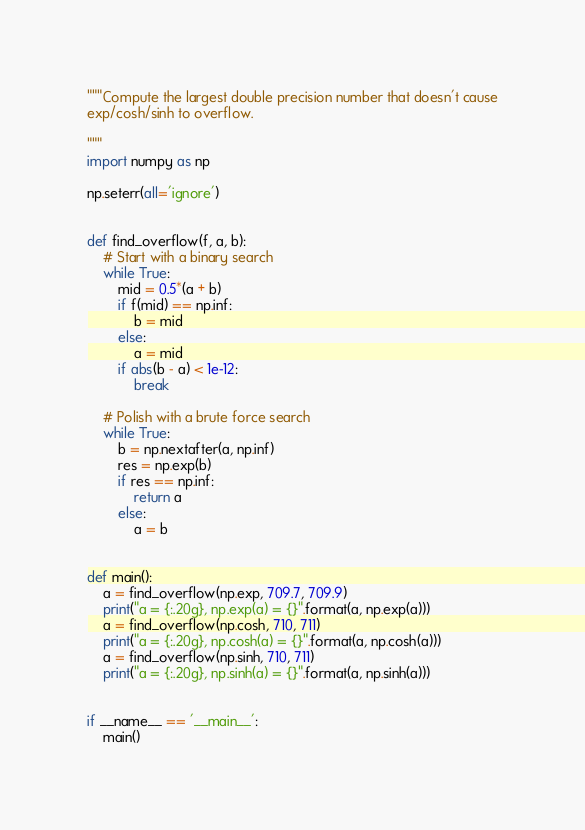<code> <loc_0><loc_0><loc_500><loc_500><_Python_>"""Compute the largest double precision number that doesn't cause
exp/cosh/sinh to overflow.

"""
import numpy as np

np.seterr(all='ignore')


def find_overflow(f, a, b):
    # Start with a binary search
    while True:
        mid = 0.5*(a + b)
        if f(mid) == np.inf:
            b = mid
        else:
            a = mid
        if abs(b - a) < 1e-12:
            break

    # Polish with a brute force search
    while True:
        b = np.nextafter(a, np.inf)
        res = np.exp(b)
        if res == np.inf:
            return a
        else:
            a = b


def main():
    a = find_overflow(np.exp, 709.7, 709.9)
    print("a = {:.20g}, np.exp(a) = {}".format(a, np.exp(a)))
    a = find_overflow(np.cosh, 710, 711)
    print("a = {:.20g}, np.cosh(a) = {}".format(a, np.cosh(a)))
    a = find_overflow(np.sinh, 710, 711)
    print("a = {:.20g}, np.sinh(a) = {}".format(a, np.sinh(a)))


if __name__ == '__main__':
    main()
</code> 